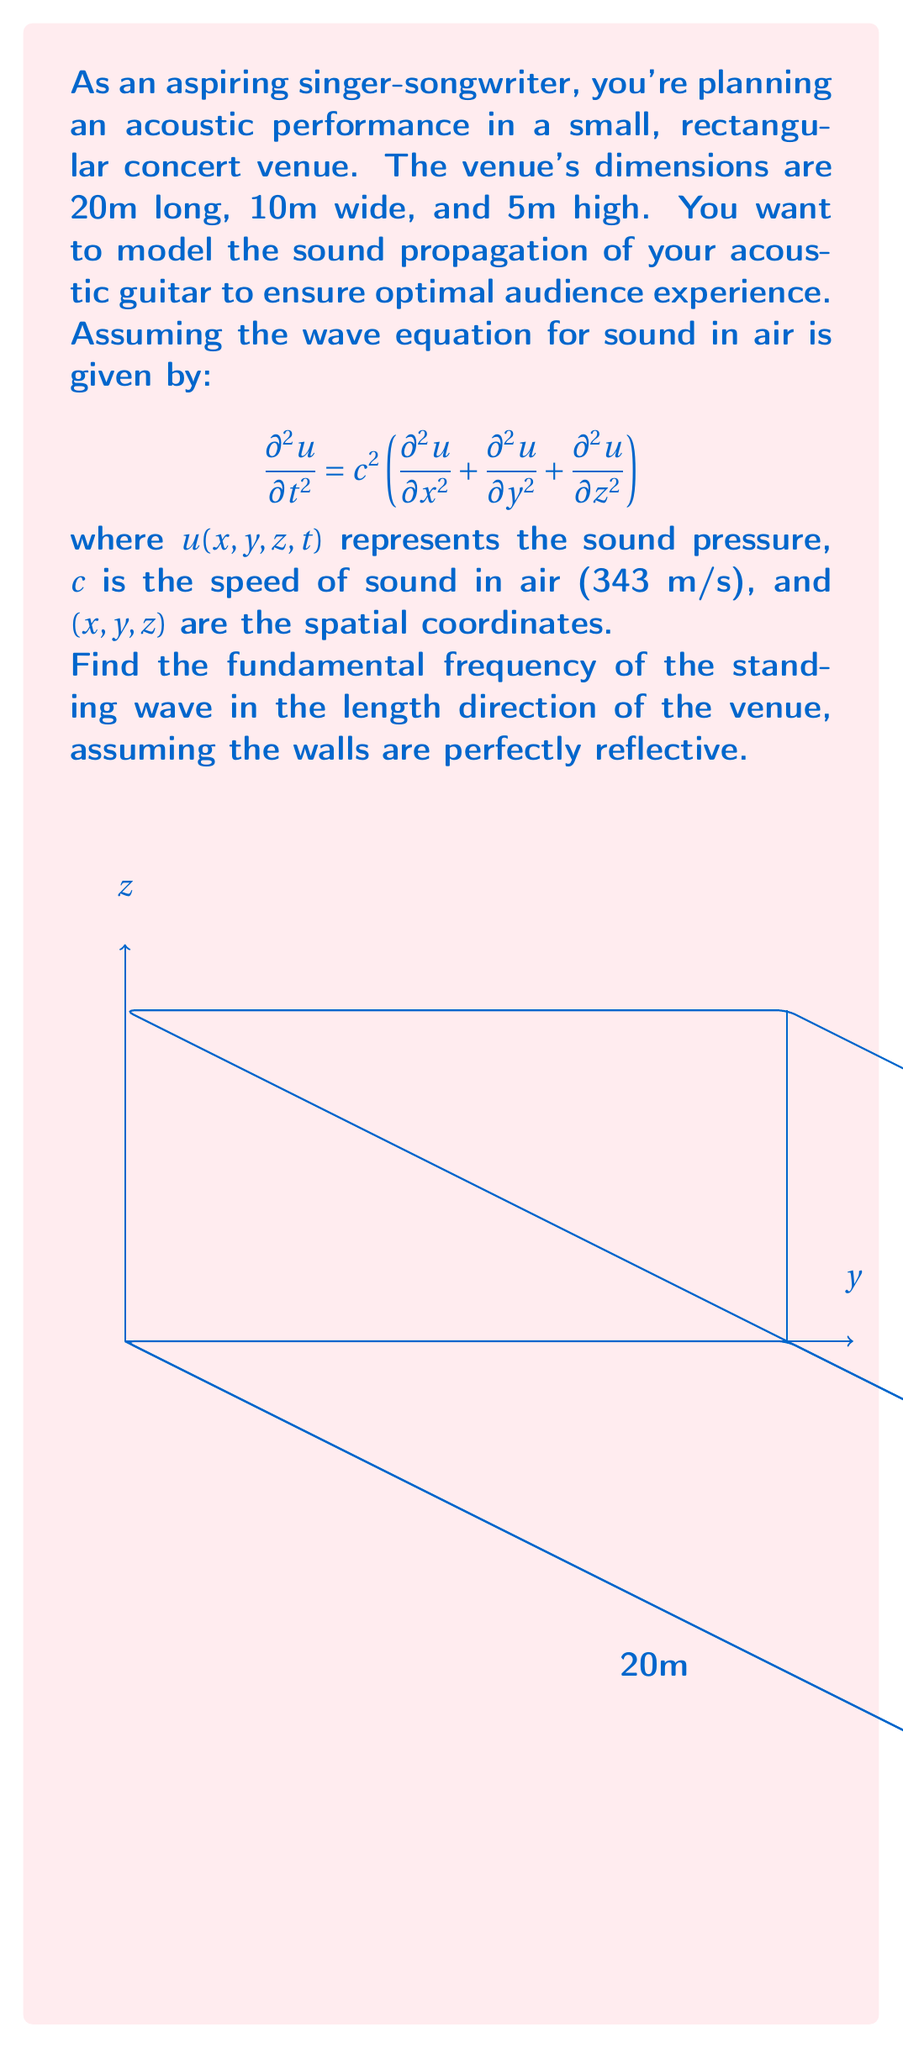Help me with this question. To solve this problem, we'll follow these steps:

1) For a standing wave in a rectangular enclosure, we can separate the variables:
   $u(x,y,z,t) = X(x)Y(y)Z(z)T(t)$

2) Focusing on the length direction (x-axis), we have the boundary conditions:
   $X(0) = X(L) = 0$, where $L = 20$ m (length of the venue)

3) The solution for $X(x)$ that satisfies these boundary conditions is:
   $X(x) = \sin(k_x x)$, where $k_x = \frac{n\pi}{L}$ and $n$ is a positive integer

4) The fundamental frequency corresponds to $n = 1$, so:
   $k_x = \frac{\pi}{L} = \frac{\pi}{20}$ m^(-1)

5) The angular frequency $\omega$ is related to $k_x$ by the dispersion relation:
   $\omega = ck_x$

6) Therefore, the fundamental angular frequency is:
   $\omega = c \cdot \frac{\pi}{L} = 343 \cdot \frac{\pi}{20}$ rad/s

7) Convert angular frequency to regular frequency:
   $f = \frac{\omega}{2\pi} = \frac{343}{2L} = \frac{343}{2 \cdot 20} = 8.575$ Hz

Thus, the fundamental frequency of the standing wave in the length direction is approximately 8.575 Hz.
Answer: 8.575 Hz 